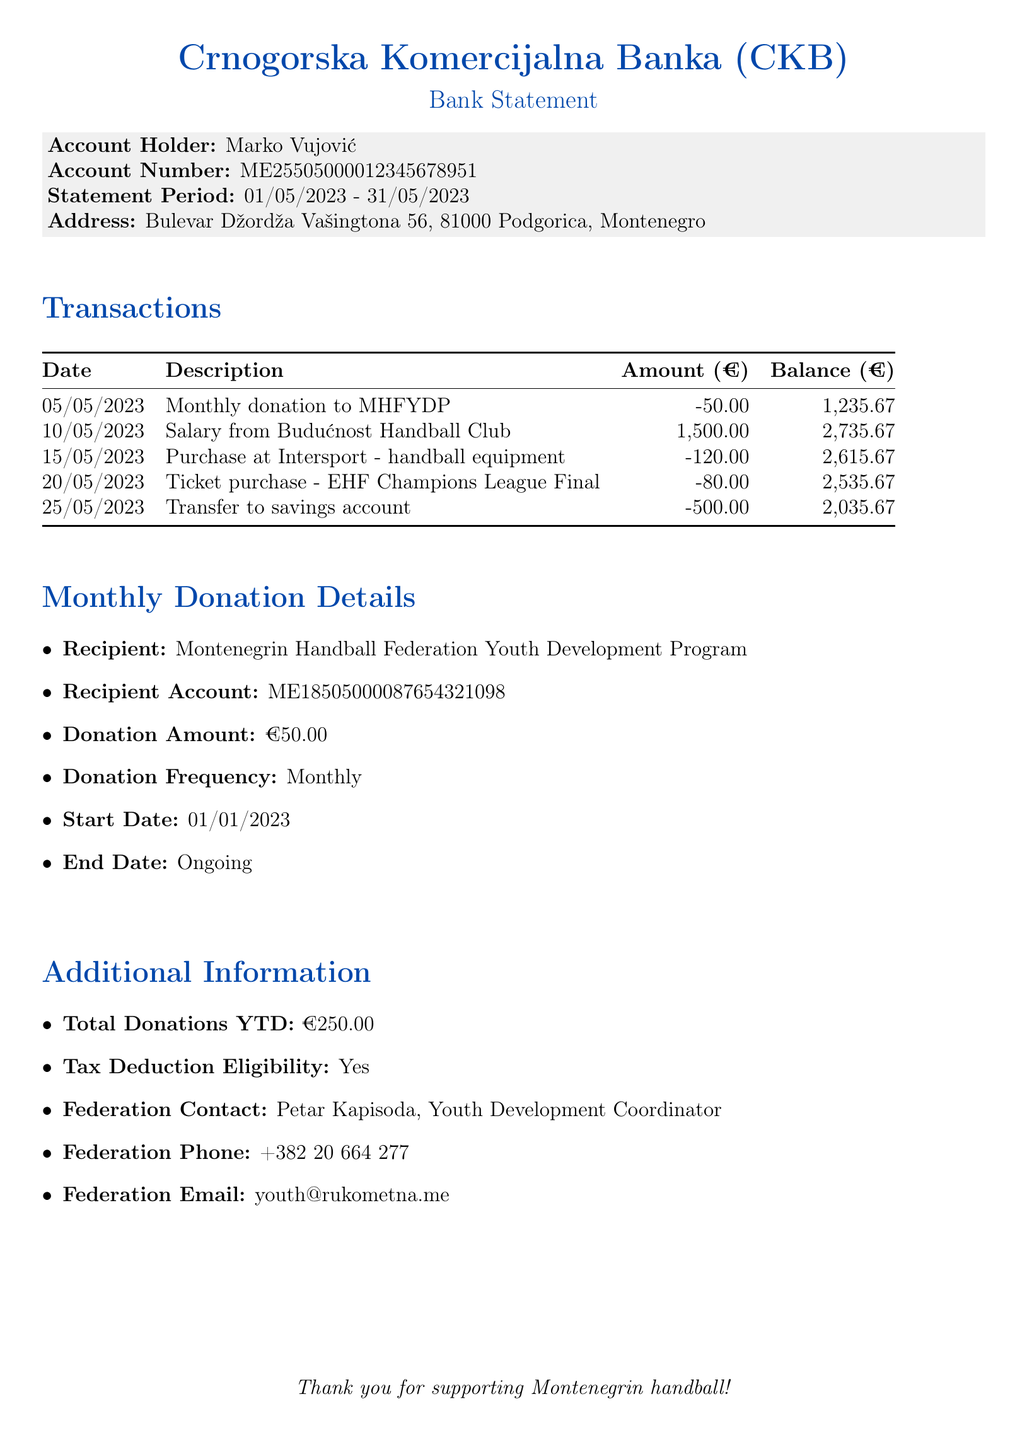What is the bank name? The bank name is listed at the top of the document.
Answer: Crnogorska Komercijalna Banka (CKB) What is the total donation amount for the year to date? The total donations year to date is specified in the additional information section of the document.
Answer: 250.00 What date did the monthly donation to MHFYDP occur? The date of the donation is clearly mentioned in the transaction section.
Answer: 05/05/2023 Who is the contact person for the federation? The federation contact is provided in the additional information section.
Answer: Petar Kapisoda What is the amount of the monthly donation? The monthly donation amount is specified in the monthly donation details.
Answer: 50.00 What was the balance after the donation on 05/05/2023? The balance is shown in the transactions section after the donation entry.
Answer: 1,235.67 What is the starting date for the monthly donations? The start date for the monthly donations is mentioned in the monthly donation details.
Answer: 01/01/2023 What type of transaction was made on 15/05/2023? The description of the transaction clearly indicates the type of transaction made on that date.
Answer: Purchase at Intersport - handball equipment How frequently are the donations made? The donation frequency is specified in the monthly donation details.
Answer: Monthly 